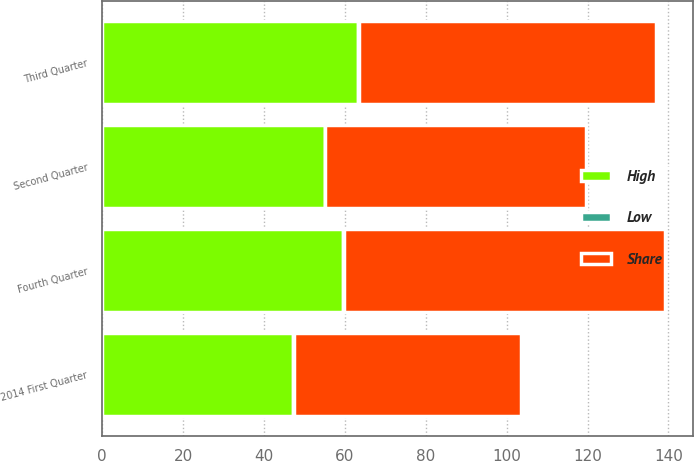<chart> <loc_0><loc_0><loc_500><loc_500><stacked_bar_chart><ecel><fcel>2014 First Quarter<fcel>Second Quarter<fcel>Third Quarter<fcel>Fourth Quarter<nl><fcel>Share<fcel>56.2<fcel>64.31<fcel>73.28<fcel>79.25<nl><fcel>High<fcel>47.21<fcel>55<fcel>63.37<fcel>59.61<nl><fcel>Low<fcel>0.17<fcel>0.2<fcel>0.2<fcel>0.2<nl></chart> 